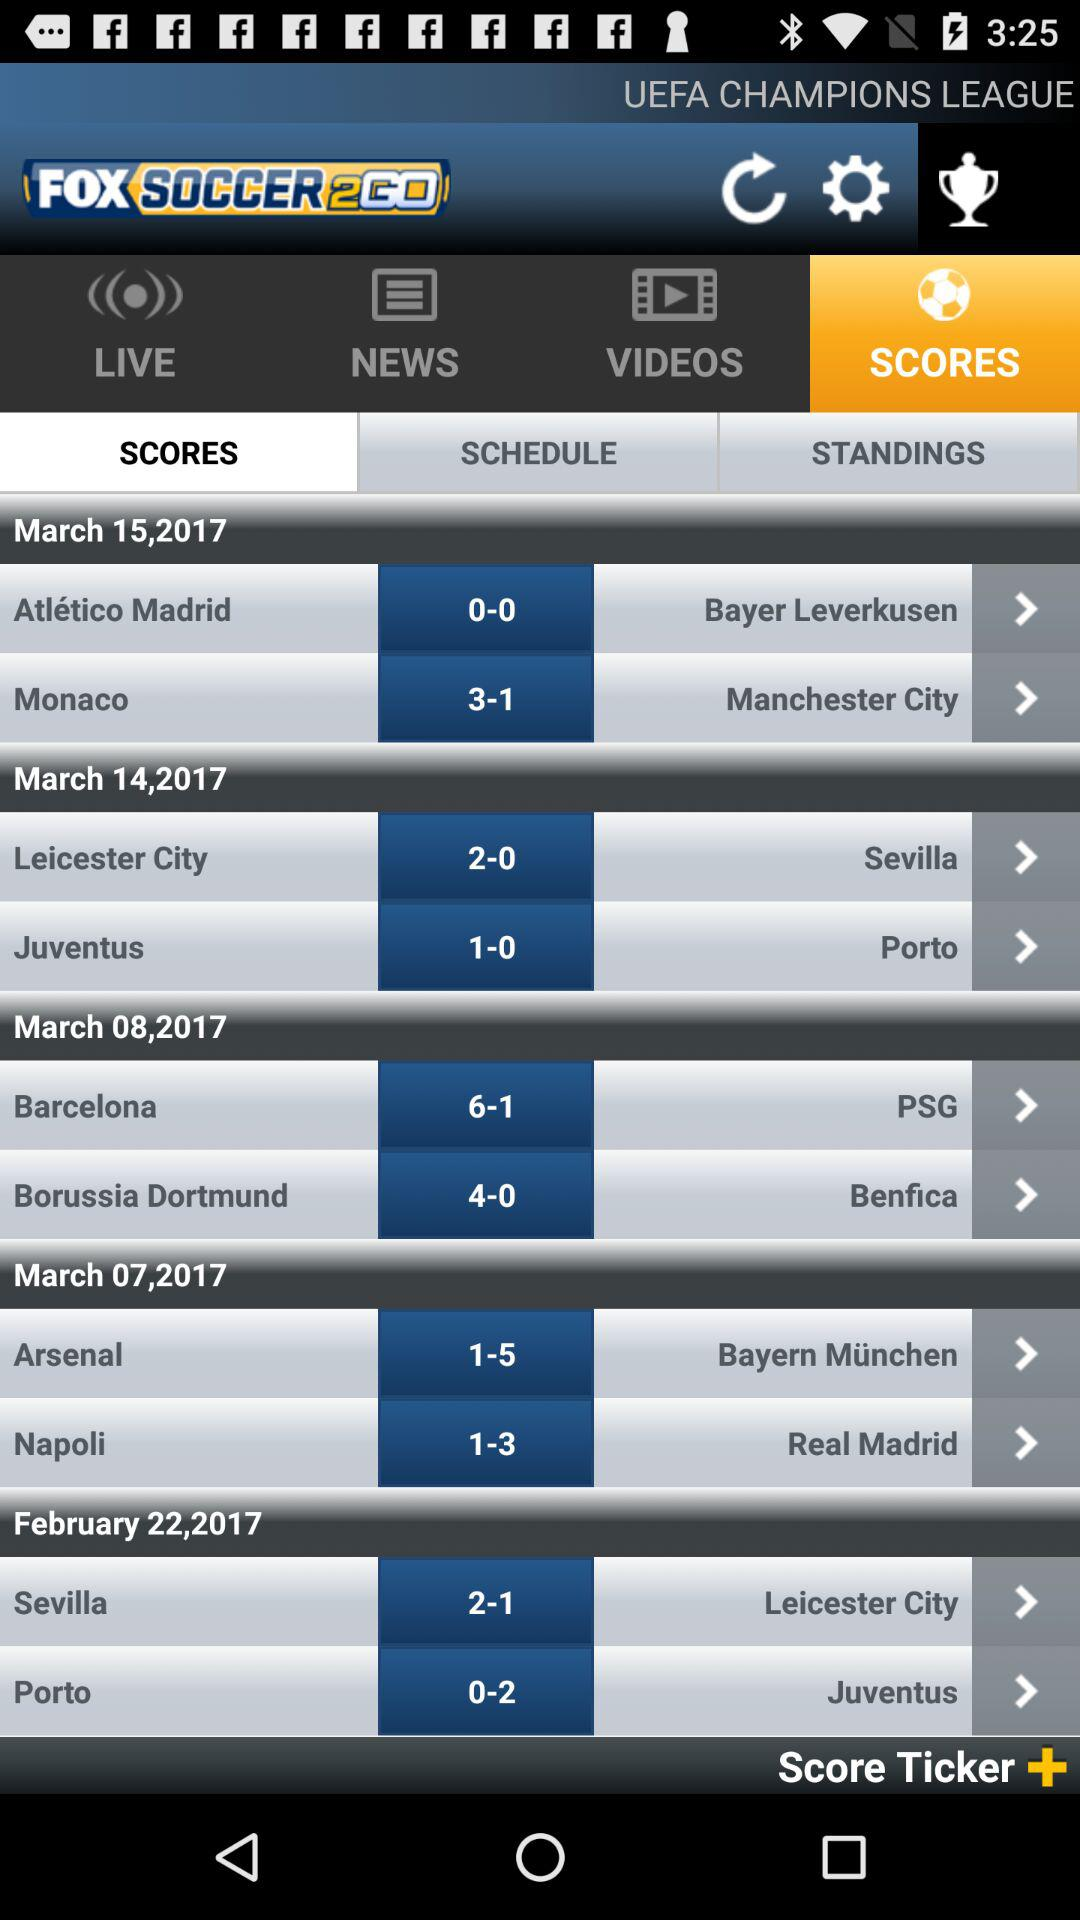Which date sevilla and porto were played?
When the provided information is insufficient, respond with <no answer>. <no answer> 